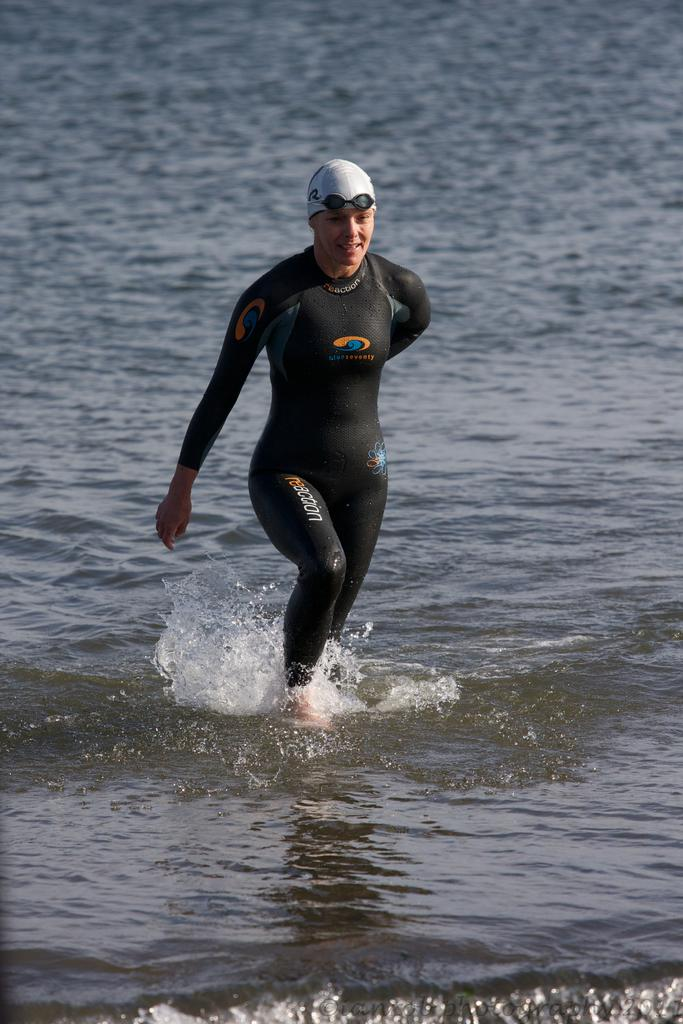What is present in the image? There is a person in the image. What is the person wearing? The person is wearing a black dress. What else can be seen in the image besides the person? There is water visible in the image. What type of rule is being enforced in the image? There is no indication of any rule or enforcement in the image; it simply shows a person wearing a black dress and water. 